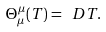Convert formula to latex. <formula><loc_0><loc_0><loc_500><loc_500>\Theta ^ { \mu } _ { \mu } ( T ) = \ D T .</formula> 